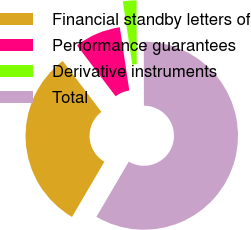Convert chart. <chart><loc_0><loc_0><loc_500><loc_500><pie_chart><fcel>Financial standby letters of<fcel>Performance guarantees<fcel>Derivative instruments<fcel>Total<nl><fcel>31.22%<fcel>7.96%<fcel>2.34%<fcel>58.48%<nl></chart> 